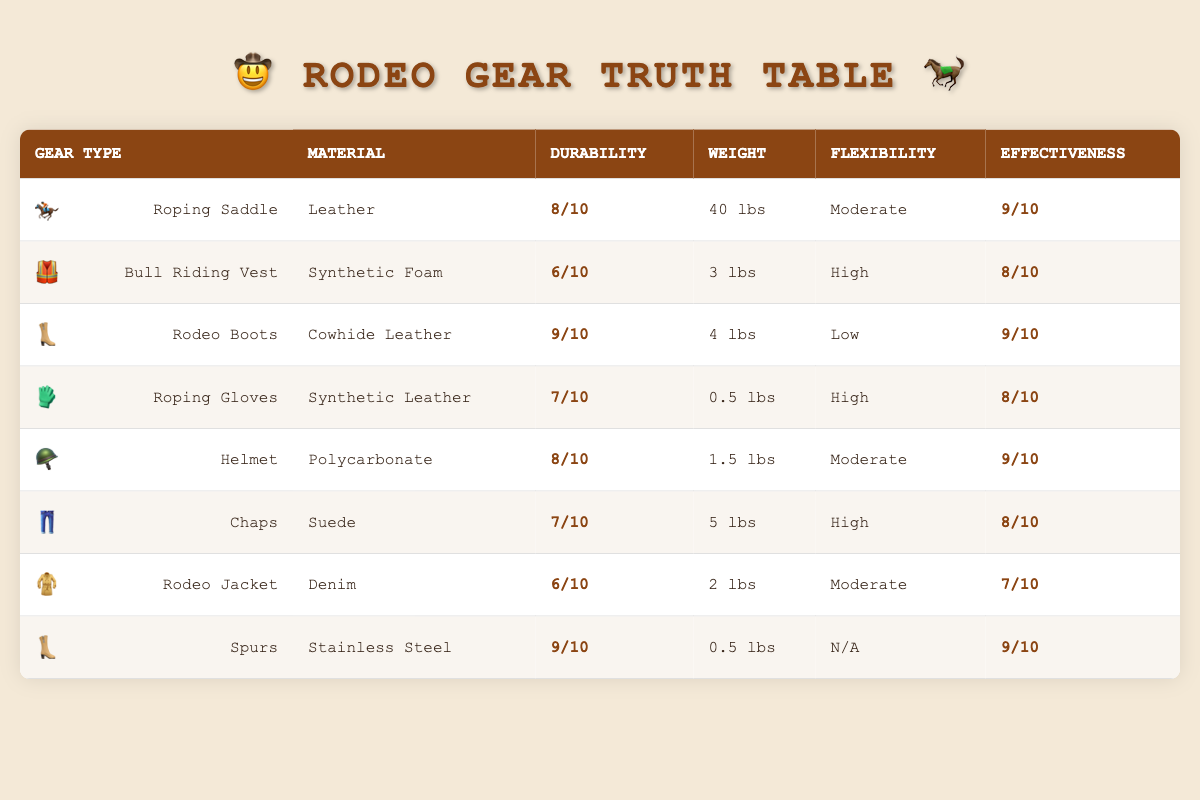What is the weight of the Bull Riding Vest? From the table, we can see the specific information for the Bull Riding Vest, which states that its weight is 3 lbs.
Answer: 3 lbs Which rodeo gear has the highest durability rating? The table lists the durability ratings for each gear type. Upon comparing, Rodeo Boots has the highest durability rating of 9.
Answer: Rodeo Boots Is the flexibility of the Roping Gloves high? In the table, Roping Gloves is noted to have high flexibility, confirming that its flexibility is indeed high.
Answer: Yes What is the combined durability rating of Roping Saddle and Chaps? The durability rating for Roping Saddle is 8 and for Chaps is 7. Summing these gives 8 + 7 = 15.
Answer: 15 Which material is used for the Helmet? The table specifies that the Helmet is made from Polycarbonate.
Answer: Polycarbonate Is there any gear listed with a flexibility labeled as "N/A"? The table lists Spurs, and its flexibility is noted as N/A, indicating that it indeed lacks a flexibility rating.
Answer: Yes What is the average effectiveness rating of the rodeo gear listed? To find the average effectiveness rating, we sum the ratings: (9 + 8 + 9 + 8 + 9 + 8 + 7 + 9) = 67. Dividing by the number of gear types (8), we get 67 / 8 = 8.375.
Answer: 8.375 How does the weight of the Roping Saddle compare to Rodeo Jacket? Roping Saddle weighs 40 lbs and Rodeo Jacket weighs 2 lbs. Thus, Roping Saddle is significantly heavier.
Answer: Heavier What is the material for Rodeo Boots? The table indicates that Rodeo Boots are made of Cowhide Leather.
Answer: Cowhide Leather 